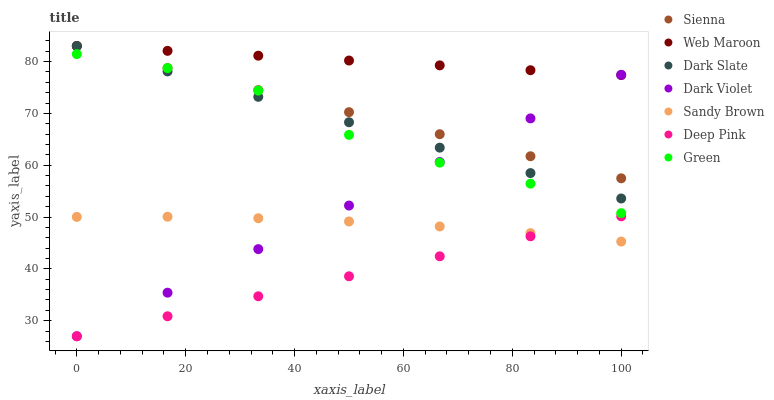Does Deep Pink have the minimum area under the curve?
Answer yes or no. Yes. Does Web Maroon have the maximum area under the curve?
Answer yes or no. Yes. Does Dark Violet have the minimum area under the curve?
Answer yes or no. No. Does Dark Violet have the maximum area under the curve?
Answer yes or no. No. Is Dark Violet the smoothest?
Answer yes or no. Yes. Is Green the roughest?
Answer yes or no. Yes. Is Web Maroon the smoothest?
Answer yes or no. No. Is Web Maroon the roughest?
Answer yes or no. No. Does Deep Pink have the lowest value?
Answer yes or no. Yes. Does Web Maroon have the lowest value?
Answer yes or no. No. Does Dark Slate have the highest value?
Answer yes or no. Yes. Does Dark Violet have the highest value?
Answer yes or no. No. Is Sandy Brown less than Web Maroon?
Answer yes or no. Yes. Is Green greater than Deep Pink?
Answer yes or no. Yes. Does Web Maroon intersect Sienna?
Answer yes or no. Yes. Is Web Maroon less than Sienna?
Answer yes or no. No. Is Web Maroon greater than Sienna?
Answer yes or no. No. Does Sandy Brown intersect Web Maroon?
Answer yes or no. No. 